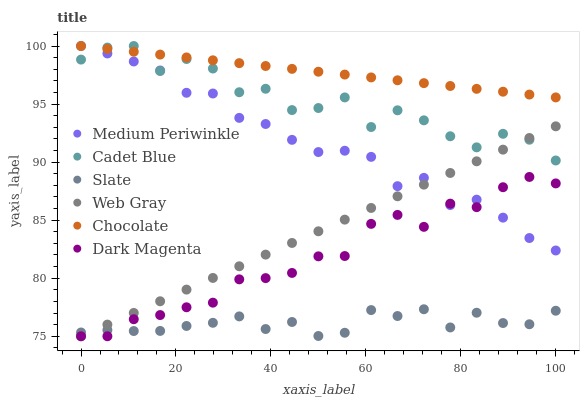Does Slate have the minimum area under the curve?
Answer yes or no. Yes. Does Chocolate have the maximum area under the curve?
Answer yes or no. Yes. Does Dark Magenta have the minimum area under the curve?
Answer yes or no. No. Does Dark Magenta have the maximum area under the curve?
Answer yes or no. No. Is Chocolate the smoothest?
Answer yes or no. Yes. Is Cadet Blue the roughest?
Answer yes or no. Yes. Is Dark Magenta the smoothest?
Answer yes or no. No. Is Dark Magenta the roughest?
Answer yes or no. No. Does Web Gray have the lowest value?
Answer yes or no. Yes. Does Slate have the lowest value?
Answer yes or no. No. Does Cadet Blue have the highest value?
Answer yes or no. Yes. Does Dark Magenta have the highest value?
Answer yes or no. No. Is Slate less than Medium Periwinkle?
Answer yes or no. Yes. Is Chocolate greater than Web Gray?
Answer yes or no. Yes. Does Medium Periwinkle intersect Dark Magenta?
Answer yes or no. Yes. Is Medium Periwinkle less than Dark Magenta?
Answer yes or no. No. Is Medium Periwinkle greater than Dark Magenta?
Answer yes or no. No. Does Slate intersect Medium Periwinkle?
Answer yes or no. No. 